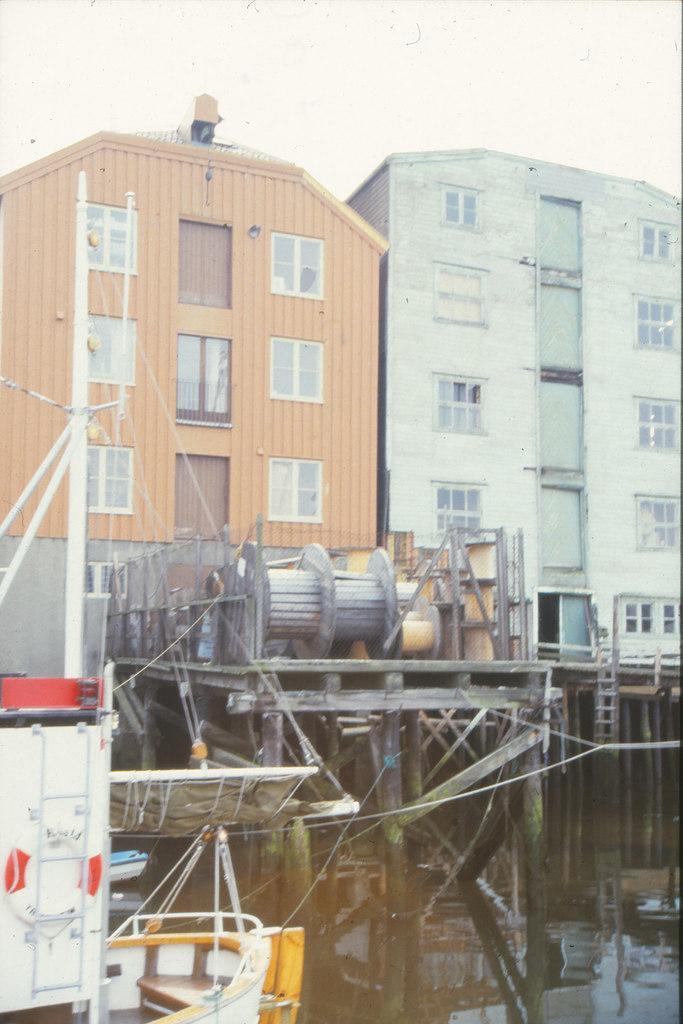Please provide a concise description of this image. In this image we can see sky, buildings, generator, water and machines. 